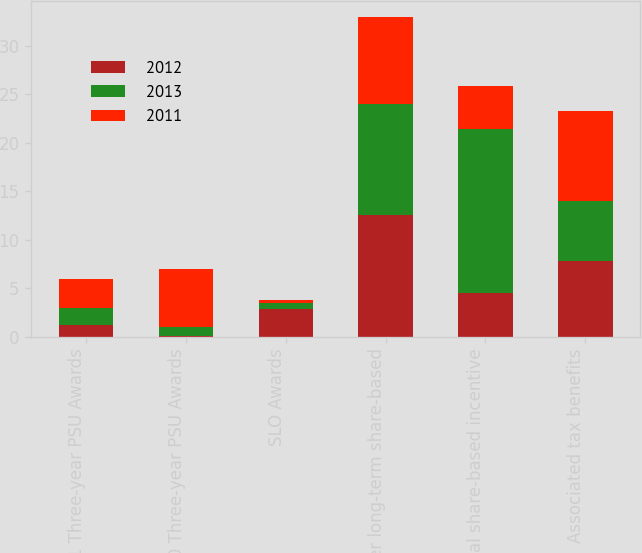Convert chart to OTSL. <chart><loc_0><loc_0><loc_500><loc_500><stacked_bar_chart><ecel><fcel>2011 Three-year PSU Awards<fcel>2010 Three-year PSU Awards<fcel>SLO Awards<fcel>Other long-term share-based<fcel>Total share-based incentive<fcel>Associated tax benefits<nl><fcel>2012<fcel>1.2<fcel>0.1<fcel>2.8<fcel>12.5<fcel>4.5<fcel>7.8<nl><fcel>2013<fcel>1.7<fcel>0.9<fcel>0.7<fcel>11.5<fcel>16.9<fcel>6.2<nl><fcel>2011<fcel>3<fcel>6<fcel>0.3<fcel>9<fcel>4.5<fcel>9.3<nl></chart> 